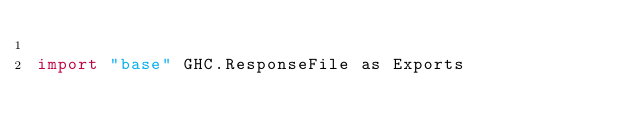Convert code to text. <code><loc_0><loc_0><loc_500><loc_500><_Haskell_>
import "base" GHC.ResponseFile as Exports
</code> 